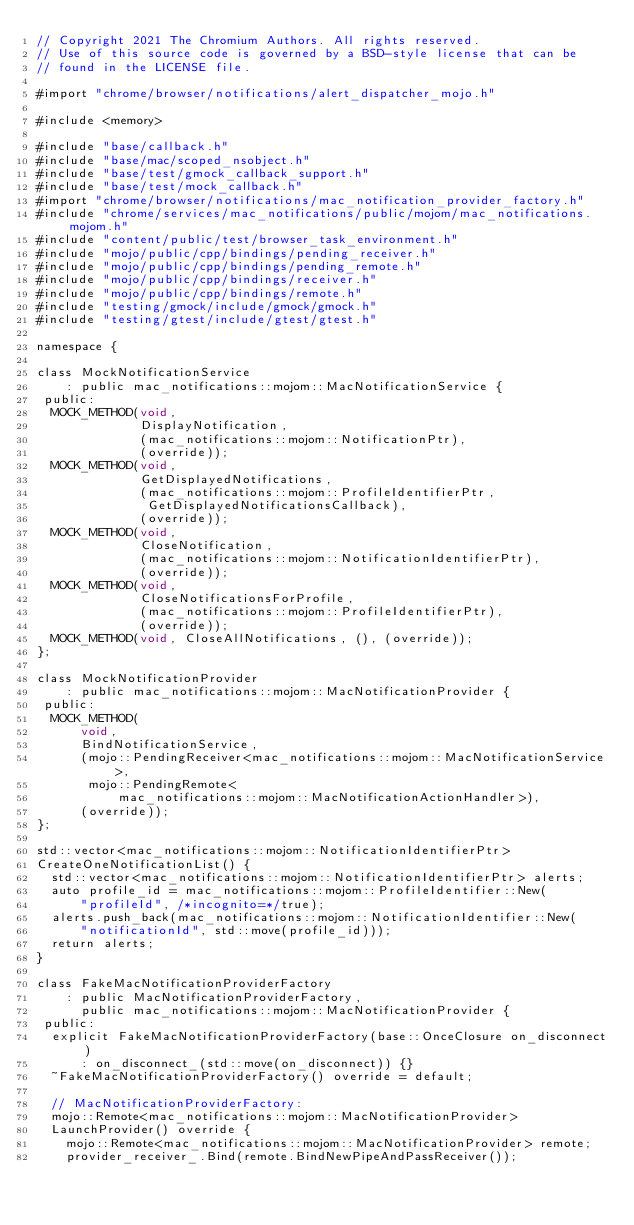<code> <loc_0><loc_0><loc_500><loc_500><_ObjectiveC_>// Copyright 2021 The Chromium Authors. All rights reserved.
// Use of this source code is governed by a BSD-style license that can be
// found in the LICENSE file.

#import "chrome/browser/notifications/alert_dispatcher_mojo.h"

#include <memory>

#include "base/callback.h"
#include "base/mac/scoped_nsobject.h"
#include "base/test/gmock_callback_support.h"
#include "base/test/mock_callback.h"
#import "chrome/browser/notifications/mac_notification_provider_factory.h"
#include "chrome/services/mac_notifications/public/mojom/mac_notifications.mojom.h"
#include "content/public/test/browser_task_environment.h"
#include "mojo/public/cpp/bindings/pending_receiver.h"
#include "mojo/public/cpp/bindings/pending_remote.h"
#include "mojo/public/cpp/bindings/receiver.h"
#include "mojo/public/cpp/bindings/remote.h"
#include "testing/gmock/include/gmock/gmock.h"
#include "testing/gtest/include/gtest/gtest.h"

namespace {

class MockNotificationService
    : public mac_notifications::mojom::MacNotificationService {
 public:
  MOCK_METHOD(void,
              DisplayNotification,
              (mac_notifications::mojom::NotificationPtr),
              (override));
  MOCK_METHOD(void,
              GetDisplayedNotifications,
              (mac_notifications::mojom::ProfileIdentifierPtr,
               GetDisplayedNotificationsCallback),
              (override));
  MOCK_METHOD(void,
              CloseNotification,
              (mac_notifications::mojom::NotificationIdentifierPtr),
              (override));
  MOCK_METHOD(void,
              CloseNotificationsForProfile,
              (mac_notifications::mojom::ProfileIdentifierPtr),
              (override));
  MOCK_METHOD(void, CloseAllNotifications, (), (override));
};

class MockNotificationProvider
    : public mac_notifications::mojom::MacNotificationProvider {
 public:
  MOCK_METHOD(
      void,
      BindNotificationService,
      (mojo::PendingReceiver<mac_notifications::mojom::MacNotificationService>,
       mojo::PendingRemote<
           mac_notifications::mojom::MacNotificationActionHandler>),
      (override));
};

std::vector<mac_notifications::mojom::NotificationIdentifierPtr>
CreateOneNotificationList() {
  std::vector<mac_notifications::mojom::NotificationIdentifierPtr> alerts;
  auto profile_id = mac_notifications::mojom::ProfileIdentifier::New(
      "profileId", /*incognito=*/true);
  alerts.push_back(mac_notifications::mojom::NotificationIdentifier::New(
      "notificationId", std::move(profile_id)));
  return alerts;
}

class FakeMacNotificationProviderFactory
    : public MacNotificationProviderFactory,
      public mac_notifications::mojom::MacNotificationProvider {
 public:
  explicit FakeMacNotificationProviderFactory(base::OnceClosure on_disconnect)
      : on_disconnect_(std::move(on_disconnect)) {}
  ~FakeMacNotificationProviderFactory() override = default;

  // MacNotificationProviderFactory:
  mojo::Remote<mac_notifications::mojom::MacNotificationProvider>
  LaunchProvider() override {
    mojo::Remote<mac_notifications::mojom::MacNotificationProvider> remote;
    provider_receiver_.Bind(remote.BindNewPipeAndPassReceiver());</code> 